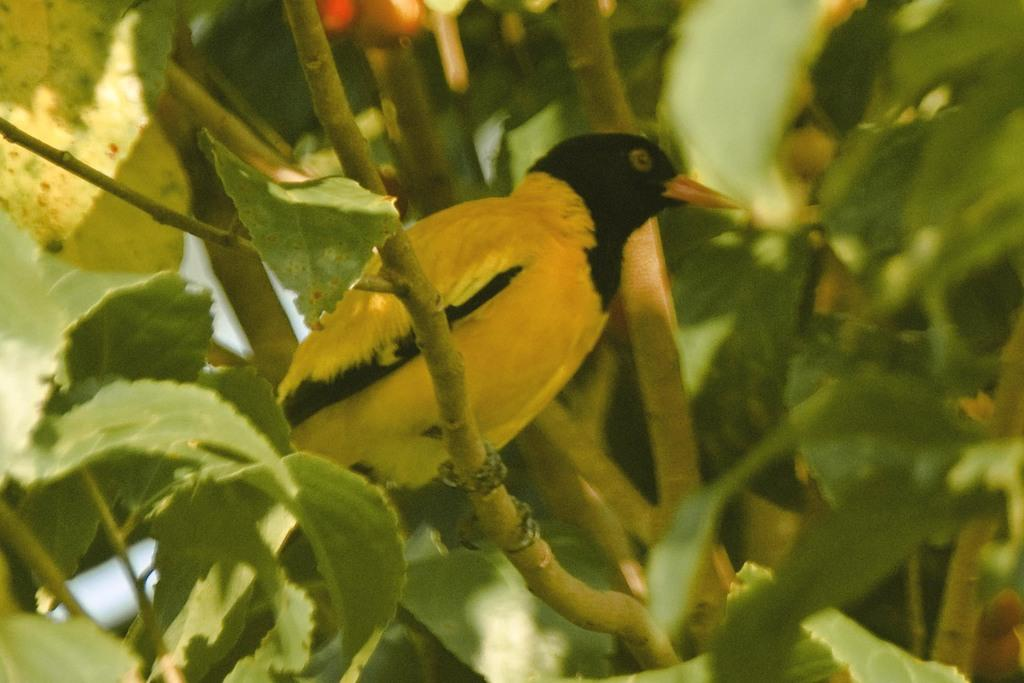What type of plant material can be seen in the image? There are green leaves and stems in the image. What type of animal is present in the image? There is a bird in the image. What colors can be seen on the bird? The bird has yellow and black coloring. What type of pen is the bird holding in the image? There is no pen present in the image; the bird is not holding anything. 